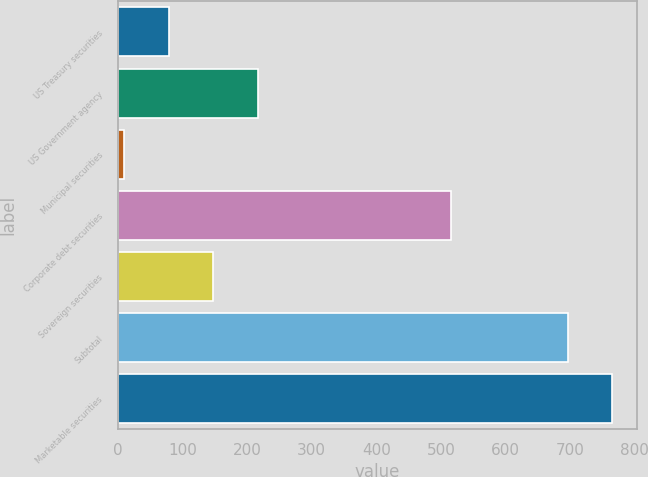Convert chart to OTSL. <chart><loc_0><loc_0><loc_500><loc_500><bar_chart><fcel>US Treasury securities<fcel>US Government agency<fcel>Municipal securities<fcel>Corporate debt securities<fcel>Sovereign securities<fcel>Subtotal<fcel>Marketable securities<nl><fcel>78.7<fcel>216.1<fcel>10<fcel>515<fcel>147.4<fcel>697<fcel>765.7<nl></chart> 